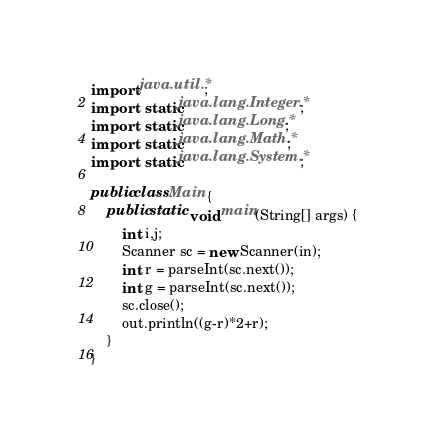<code> <loc_0><loc_0><loc_500><loc_500><_Java_>import java.util.*;
import static java.lang.Integer.*;
import static java.lang.Long.*;
import static java.lang.Math.*;
import static java.lang.System.*;

public class Main {
	public static void main(String[] args) {
		int i,j;
		Scanner sc = new Scanner(in);
		int r = parseInt(sc.next());
		int g = parseInt(sc.next());
		sc.close();
		out.println((g-r)*2+r);
	}
}
</code> 